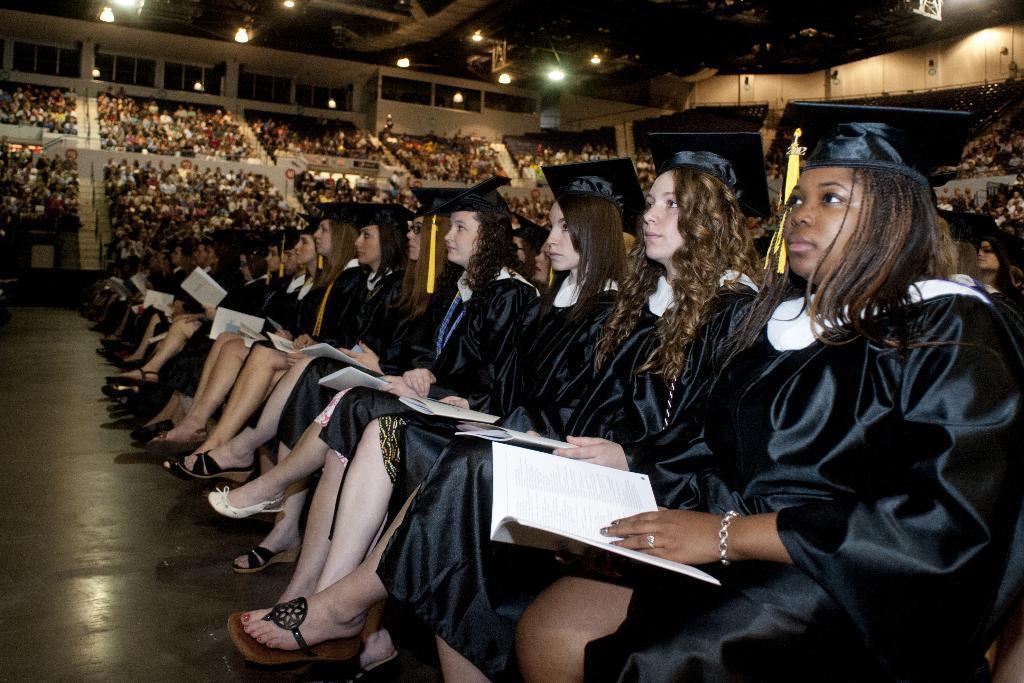Can you describe this image briefly? In this image I can see number of women wearing black dresses and black hats are sitting on chairs and holding books which are white in color in their hands. In the background I can see group of people sitting on chairs in the stadium, the ceiling of the stadium and few lights to the ceiling. 